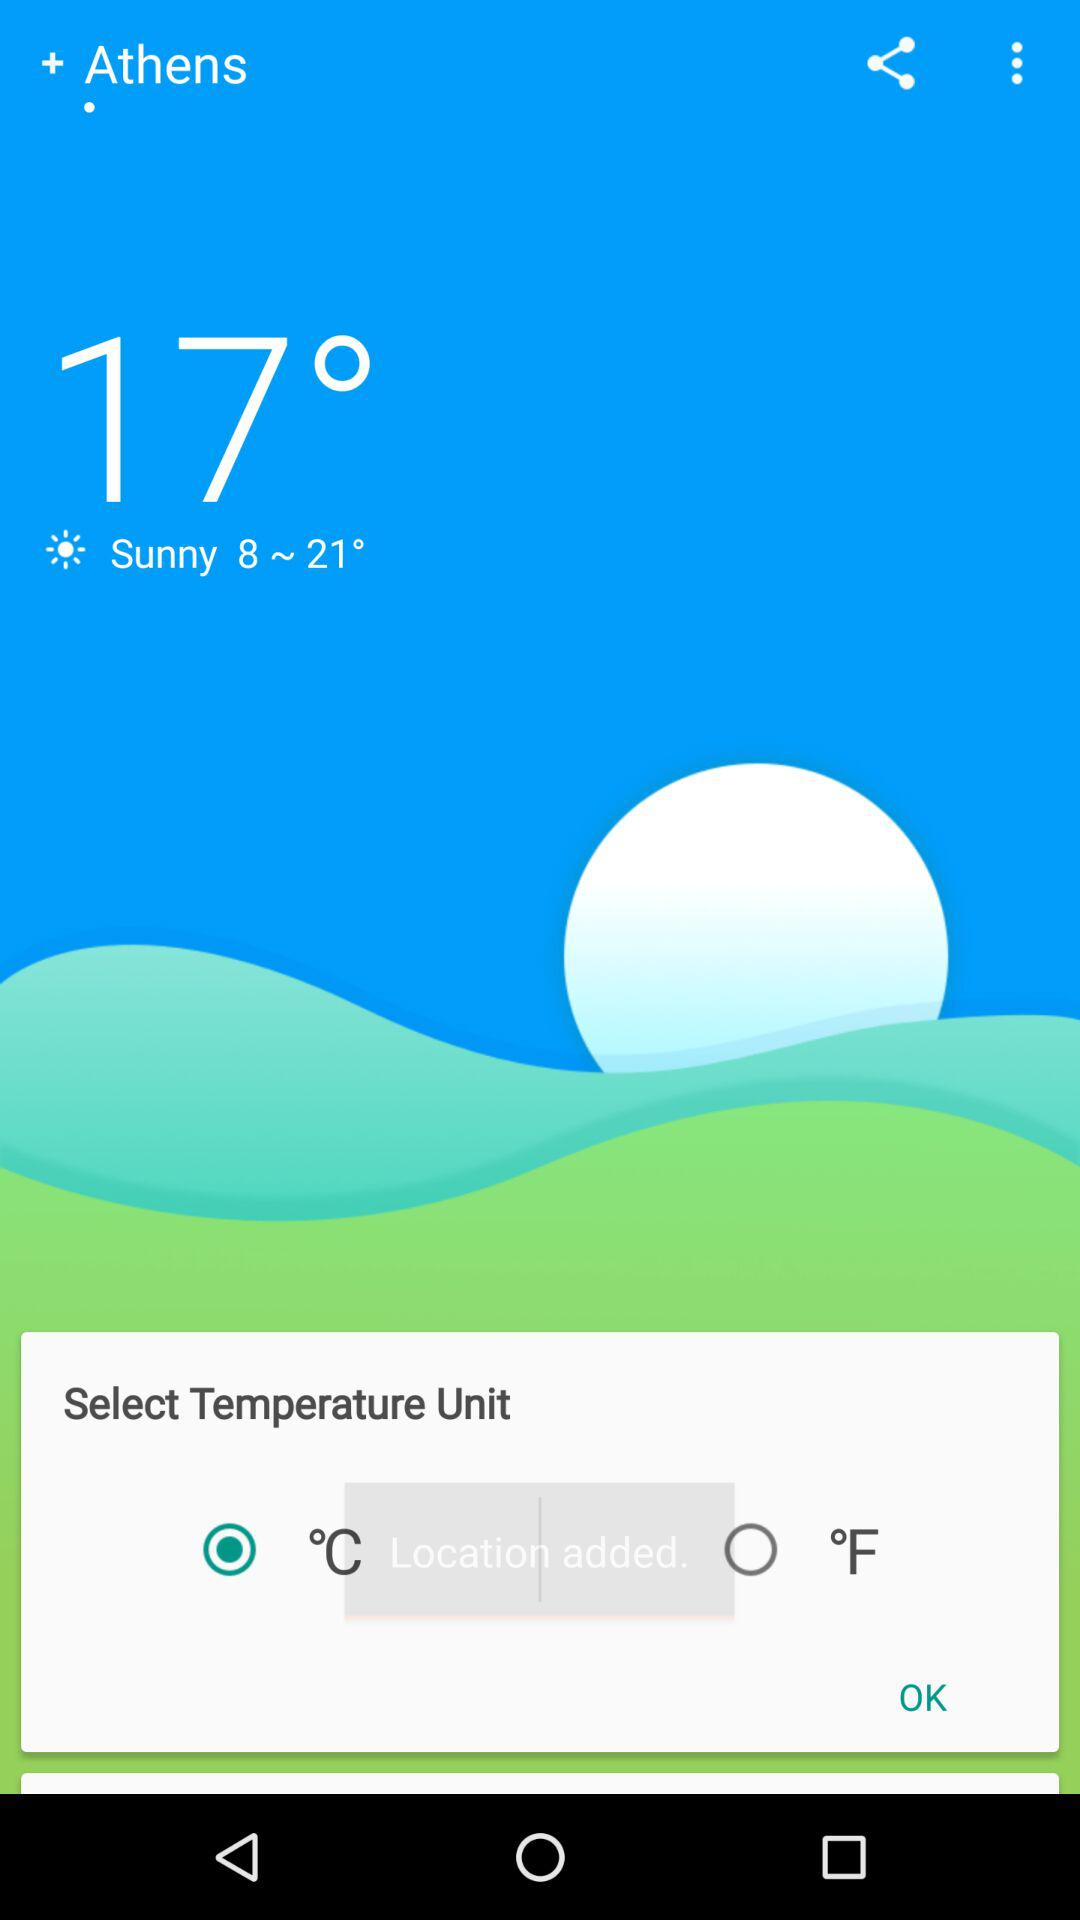What is the temperature? The temperature is 17°. 